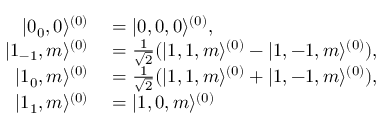<formula> <loc_0><loc_0><loc_500><loc_500>\begin{array} { r l } { | 0 _ { 0 } , 0 \rangle ^ { ( 0 ) } } & = | 0 , 0 , 0 \rangle ^ { ( 0 ) } , } \\ { | 1 _ { - 1 } , m \rangle ^ { ( 0 ) } } & = \frac { 1 } { \sqrt { 2 } } ( | 1 , 1 , m \rangle ^ { ( 0 ) } - | 1 , - 1 , m \rangle ^ { ( 0 ) } ) , } \\ { | 1 _ { 0 } , m \rangle ^ { ( 0 ) } } & = \frac { 1 } { \sqrt { 2 } } ( | 1 , 1 , m \rangle ^ { ( 0 ) } + | 1 , - 1 , m \rangle ^ { ( 0 ) } ) , } \\ { | 1 _ { 1 } , m \rangle ^ { ( 0 ) } } & = | 1 , 0 , m \rangle ^ { ( 0 ) } } \end{array}</formula> 